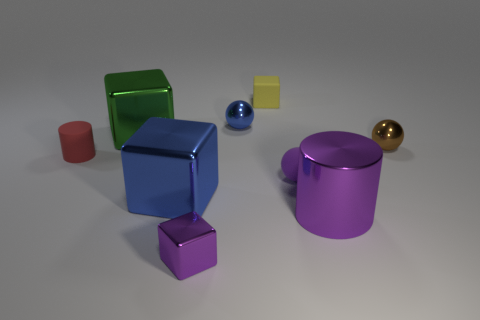What number of other things are the same size as the rubber cylinder?
Ensure brevity in your answer.  5. The green metallic block is what size?
Provide a succinct answer. Large. Is the material of the tiny red cylinder the same as the purple thing behind the big cylinder?
Your answer should be compact. Yes. Are there any other big metal things of the same shape as the red object?
Provide a short and direct response. Yes. There is a brown thing that is the same size as the red matte object; what material is it?
Your answer should be compact. Metal. What is the size of the cylinder that is to the right of the purple shiny cube?
Make the answer very short. Large. There is a purple shiny thing left of the purple metallic cylinder; does it have the same size as the matte cylinder that is to the left of the brown ball?
Offer a very short reply. Yes. What number of purple spheres are made of the same material as the blue ball?
Your response must be concise. 0. The large metal cylinder is what color?
Provide a short and direct response. Purple. There is a large green metallic thing; are there any green shiny objects in front of it?
Keep it short and to the point. No. 